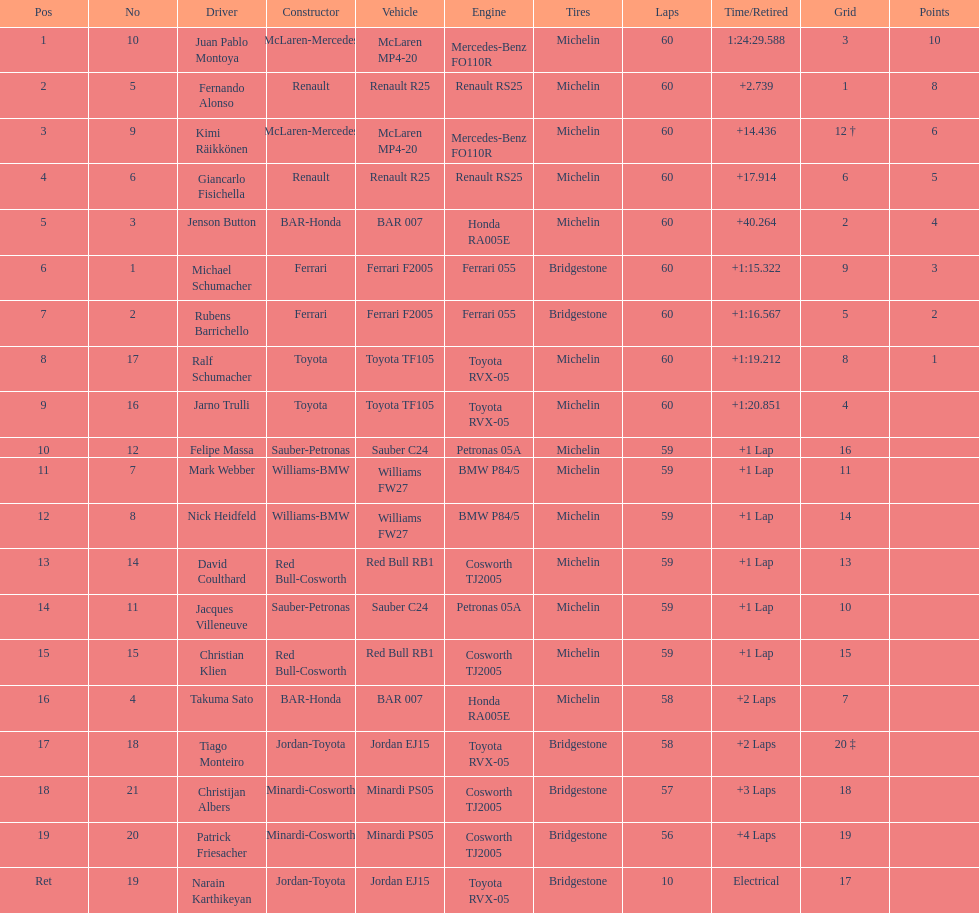Which driver in the top 8, drives a mclaran-mercedes but is not in first place? Kimi Räikkönen. 